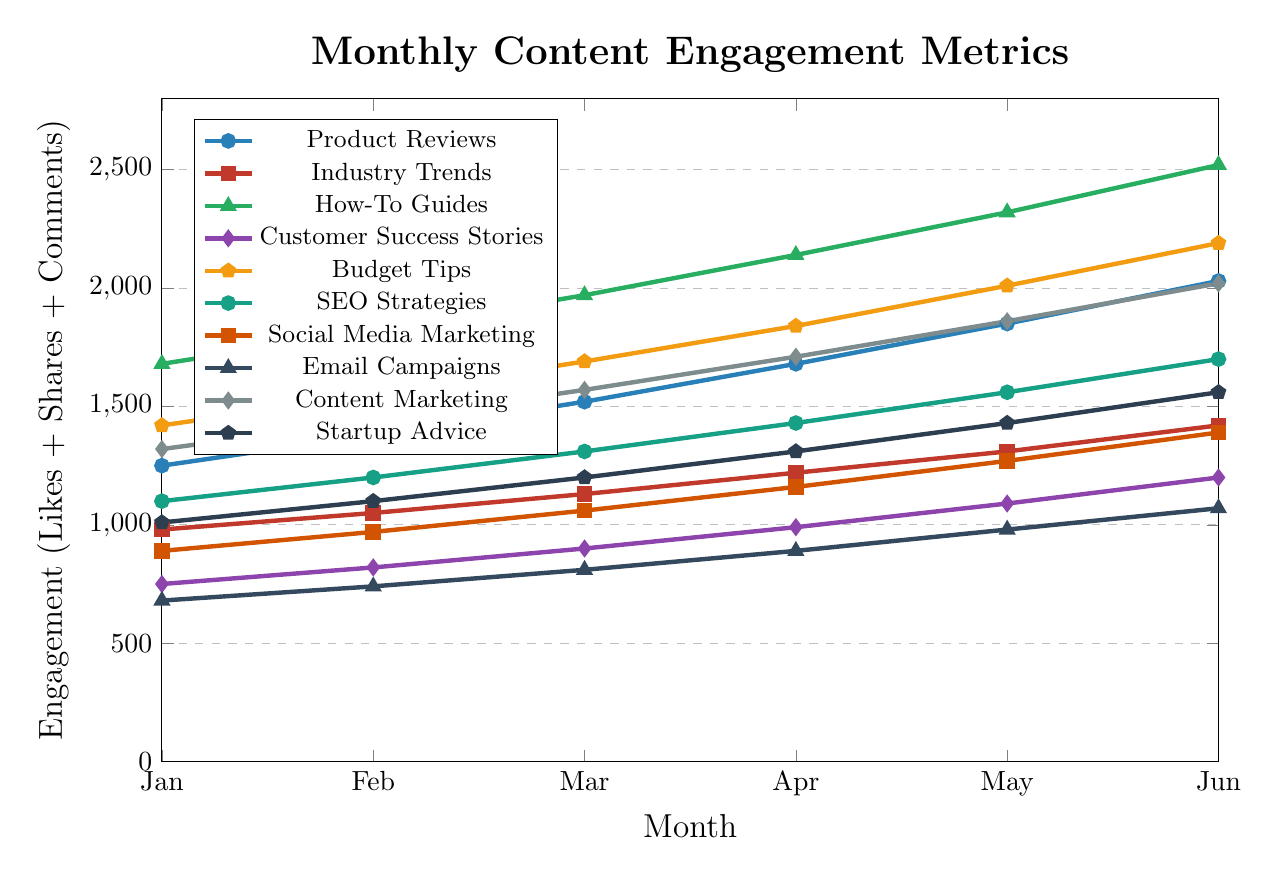What category experiences the highest engagement in June? By checking the plot, How-To Guides have the highest numerical value at June, which peaks at 2520.
Answer: How-To Guides Which category shows the steepest increase in engagement from January to June? Comparing the slopes or rate of increase for each category from January to June, How-To Guides show the steepest increase from 1680 to 2520, a rise of 840 units.
Answer: How-To Guides What is the difference in engagement between Product Reviews and Budget Tips in May? In May, Product Reviews have an engagement of 1850, and Budget Tips have 2010. The difference is 2010 - 1850 = 160.
Answer: 160 How much did Customer Success Stories' engagement grow from January to June? The engagement for Customer Success Stories grows from 750 in January to 1200 in June. The difference can be calculated as 1200 - 750 = 450.
Answer: 450 Rank the categories by their engagement in February from highest to lowest. The engagement values in February are: 
- How-To Guides: 1820
- Budget Tips: 1550
- Content Marketing: 1440
- Product Reviews: 1380
- SEO Strategies: 1200
- Startup Advice: 1100
- Industry Trends: 1050
- Social Media Marketing: 970
- Customer Success Stories: 820
- Email Campaigns: 740
So the order is:
1. How-To Guides
2. Budget Tips
3. Content Marketing
4. Product Reviews
5. SEO Strategies
6. Startup Advice
7. Industry Trends
8. Social Media Marketing
9. Customer Success Stories
10. Email Campaigns
Answer: How-To Guides, Budget Tips, Content Marketing, Product Reviews, SEO Strategies, Startup Advice, Industry Trends, Social Media Marketing, Customer Success Stories, Email Campaigns Which categories have an engagement equal to or above 2000 in any month? By checking each plotted line, both Product Reviews and How-To Guides reach or exceed 2000 in June (2030 and 2520 respectively), and Budget Tips reach 2010 and 2190 in May and June respectively. Content Marketing also hits 2020 in June.
Answer: Product Reviews, How-To Guides, Budget Tips, Content Marketing What's the average engagement for Social Media Marketing across all months? Sum of engagements for Social Media Marketing: 890 + 970 + 1060 + 1160 + 1270 + 1390 = 6740. Divide by number of months (6): 6740 / 6 = 1123.33.
Answer: 1123.33 Compare the engagement of Industry Trends and SEO Strategies in April. Which one is higher and by how much? In April, Industry Trends have an engagement of 1220, while SEO Strategies have an engagement of 1430. The difference is 1430 - 1220 = 210. SEO Strategies is higher by 210.
Answer: SEO Strategies, 210 What is the combined engagement of the top three categories in April? The top three categories in April by their engagement values are How-To Guides (2140), Budget Tips (1840), and Content Marketing (1710). Adding them: 2140 + 1840 + 1710 = 5690.
Answer: 5690 